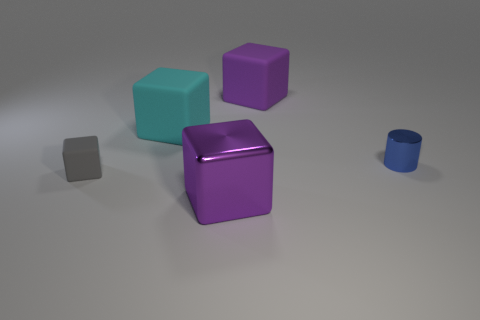Subtract all purple matte blocks. How many blocks are left? 3 Subtract all gray blocks. How many blocks are left? 3 Subtract all cylinders. How many objects are left? 4 Subtract all green cubes. Subtract all blue spheres. How many cubes are left? 4 Subtract all brown balls. How many gray blocks are left? 1 Subtract all big green rubber objects. Subtract all blue cylinders. How many objects are left? 4 Add 5 big metal objects. How many big metal objects are left? 6 Add 4 tiny gray things. How many tiny gray things exist? 5 Add 1 large matte cubes. How many objects exist? 6 Subtract 0 gray cylinders. How many objects are left? 5 